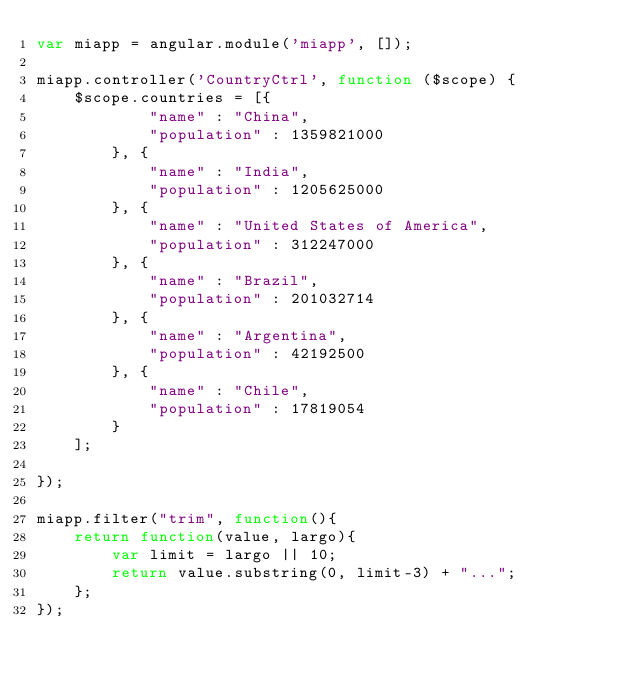<code> <loc_0><loc_0><loc_500><loc_500><_JavaScript_>var miapp = angular.module('miapp', []);

miapp.controller('CountryCtrl', function ($scope) {
	$scope.countries = [{
			"name" : "China",
			"population" : 1359821000
		}, {
			"name" : "India",
			"population" : 1205625000
		}, {
			"name" : "United States of America",
			"population" : 312247000
		}, {
			"name" : "Brazil",
			"population" : 201032714
		}, {
			"name" : "Argentina",
			"population" : 42192500
		}, {
			"name" : "Chile",
			"population" : 17819054
		}
	];

});

miapp.filter("trim", function(){
	return function(value, largo){
		var limit = largo || 10;
		return value.substring(0, limit-3) + "...";	
	};
});
</code> 